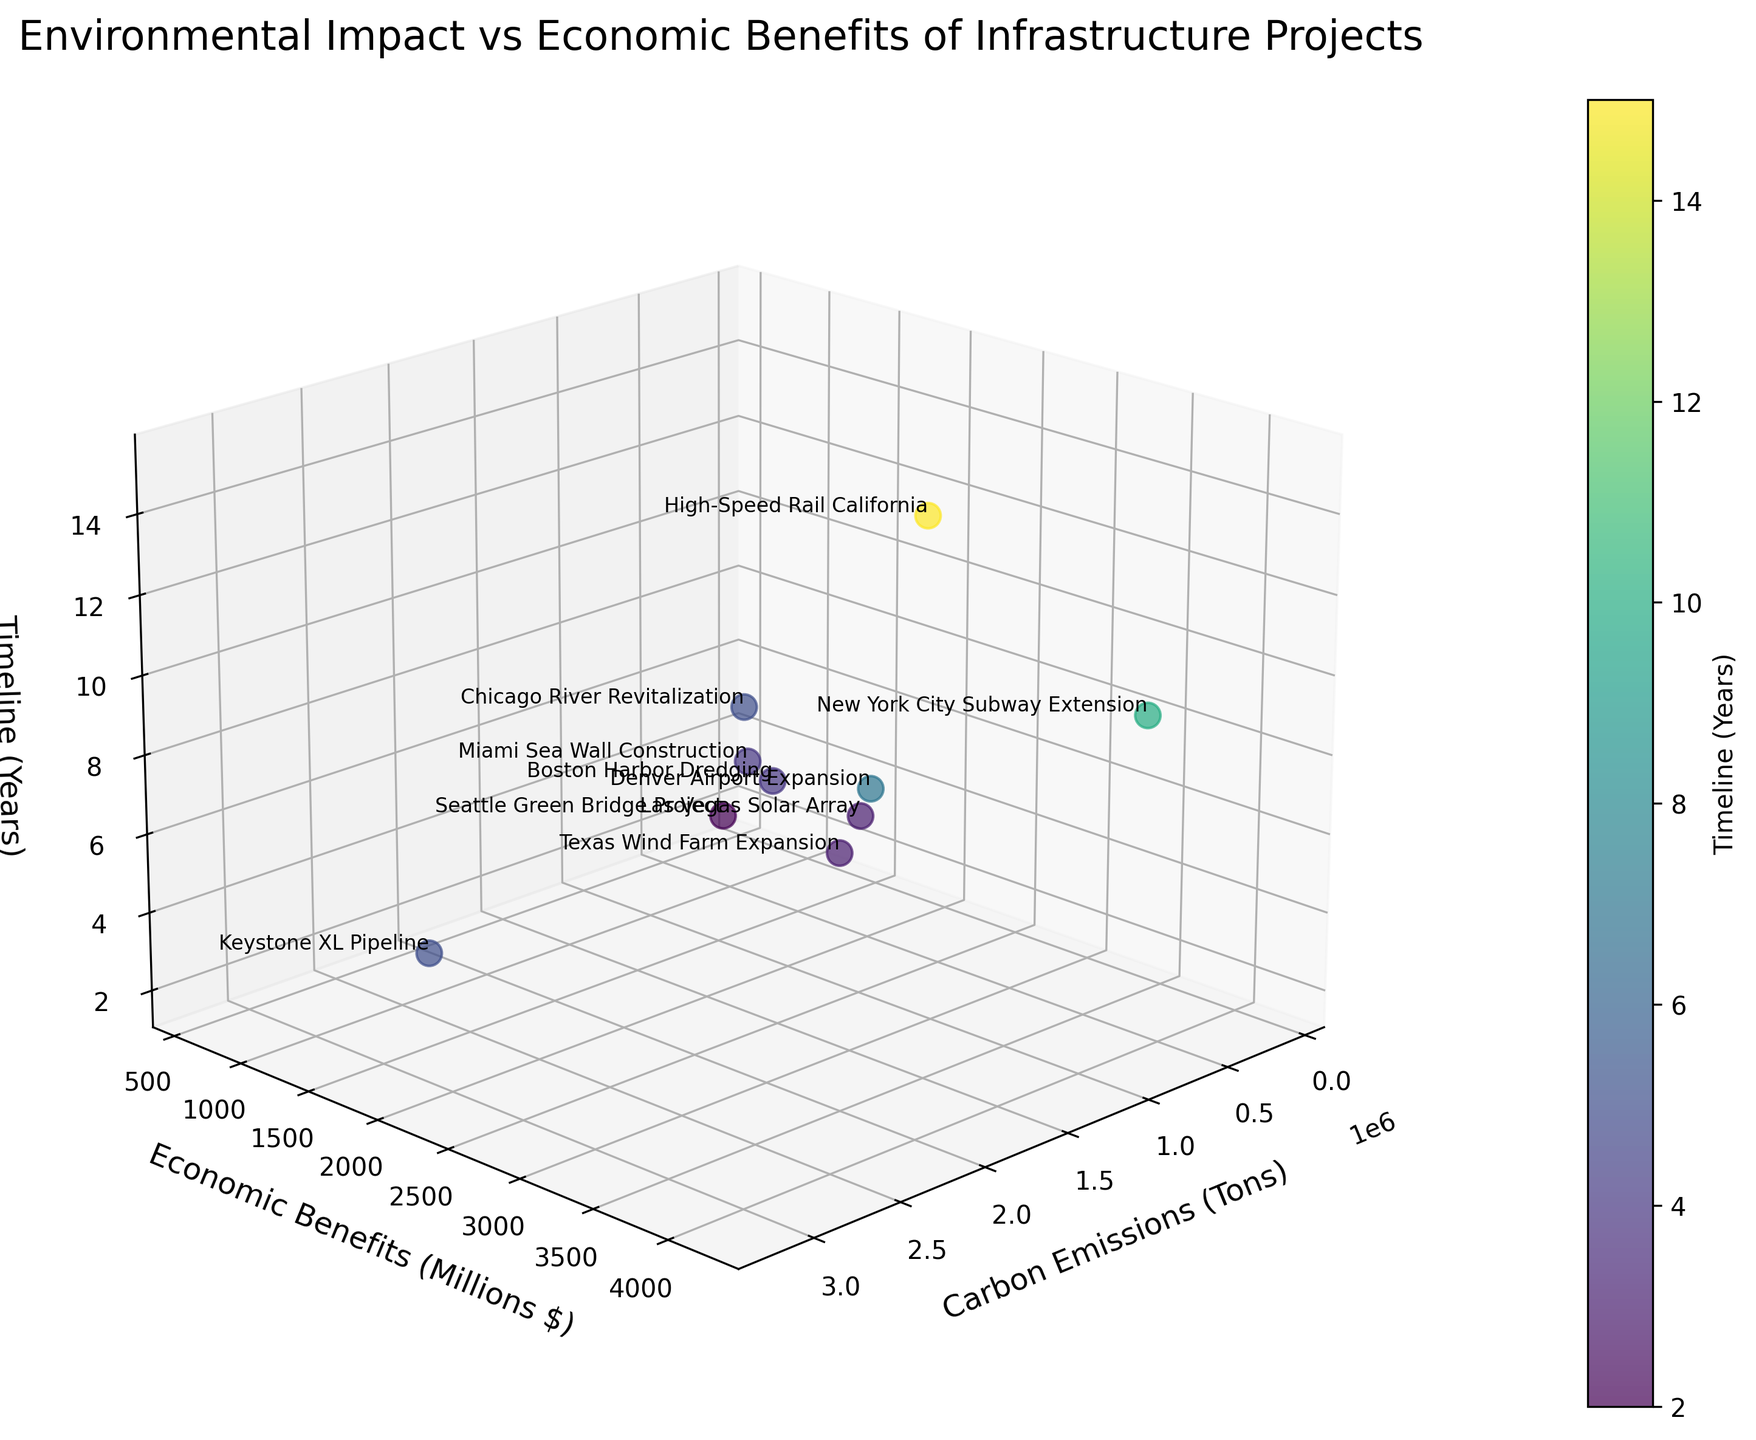What is the title of the figure? The title of the figure is located at the top of the plot. It describes the central theme portrayed in the visual representation.
Answer: Environmental Impact vs Economic Benefits of Infrastructure Projects Which project has the highest carbon emissions? To find the project with the highest carbon emissions, one needs to look at the x-axis and observe the project labeled at the highest point.
Answer: Keystone XL Pipeline Which project has the shortest timeline? To determine the project with the shortest timeline, look at the z-axis and locate the project with the lowest value.
Answer: Seattle Green Bridge Project How many projects have carbon emissions between 100,000 and 500,000 tons? Identify and count the data points along the x-axis that fall within the range between 100,000 and 500,000 tons to get the answer.
Answer: 5 Which project offers the highest economic benefits? The project with the highest economic benefits will be positioned at the highest point on the y-axis.
Answer: New York City Subway Extension What is the average timeline for the projects that have economic benefits over 3000 million dollars? First, identify the projects with economic benefits over 3000 million dollars. Then, find their corresponding timeline values and calculate the average. There are two projects: 'High-Speed Rail California' (15 years) and 'New York City Subway Extension' (10 years). Average = (15 + 10) / 2 = 12.5 years
Answer: 12.5 years Which project has the lowest carbon emissions, and what are its economic benefits? Locate the project with the lowest value on the x-axis for carbon emissions and then read off its economic benefits from the y-axis.
Answer: Las Vegas Solar Array, 1500 million dollars Compare the carbon emissions and economic benefits of the 'Keystone XL Pipeline' and 'Chicago River Revitalization.' Which one has a better ratio of economic benefits to carbon emissions? Calculate the ratio of economic benefits to carbon emissions for both projects: 
Keystone XL Pipeline: 2100 / 3200000 = 0.00065625 
Chicago River Revitalization: 700 / 150000 = 0.00466667 
Compare the two ratios to see which is higher.
Answer: Chicago River Revitalization Do projects with longer timelines tend to have higher economic benefits? Observe the general trend by looking at the z-axis (timeline) and y-axis (economic benefits). Note if projects with longer timelines (higher z-values) tend to be associated with higher y-values, indicating higher economic benefits.
Answer: Yes Which project combines lower carbon emissions and shorter timelines most effectively? Locate projects that are positioned low on the x-axis (lower carbon emissions) and z-axis (shorter timelines). Identify the one balancing both criteria well.
Answer: Seattle Green Bridge Project 